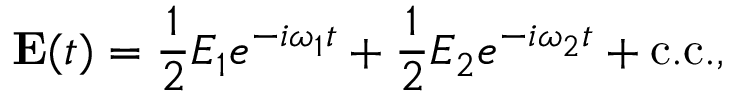<formula> <loc_0><loc_0><loc_500><loc_500>E ( t ) = { \frac { 1 } { 2 } } E _ { 1 } e ^ { - i \omega _ { 1 } t } + { \frac { 1 } { 2 } } E _ { 2 } e ^ { - i \omega _ { 2 } t } + { c . c . } ,</formula> 